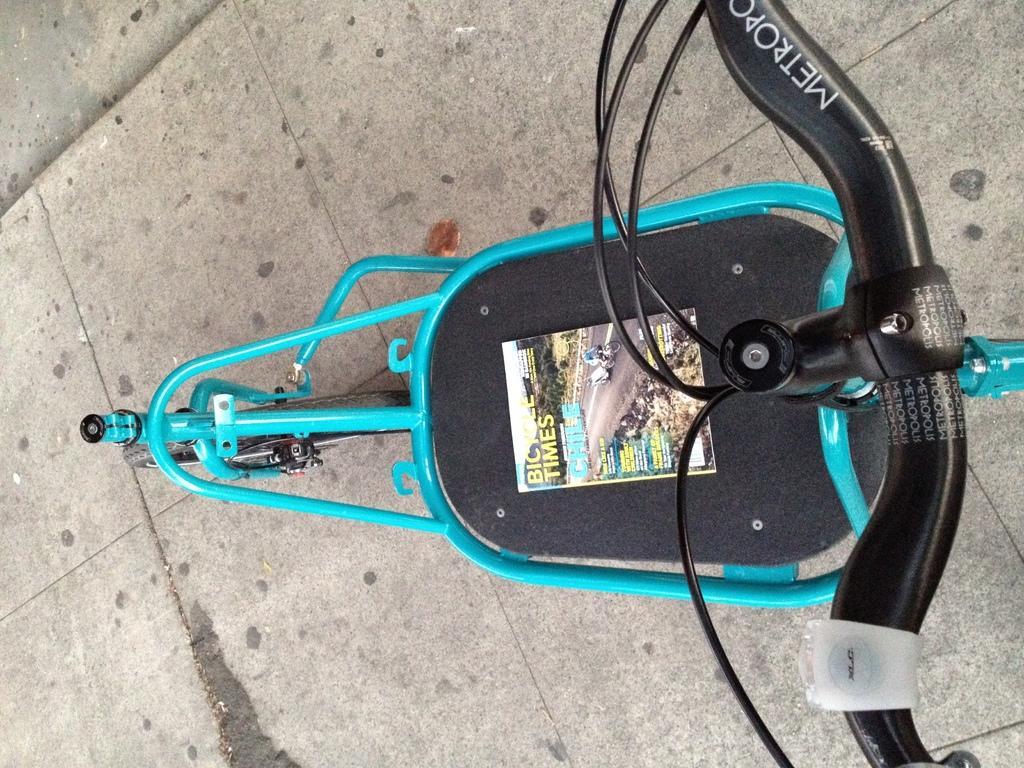Could you give a brief overview of what you see in this image? This picture looks like a bicycle and I can see a poster with some text on it. 